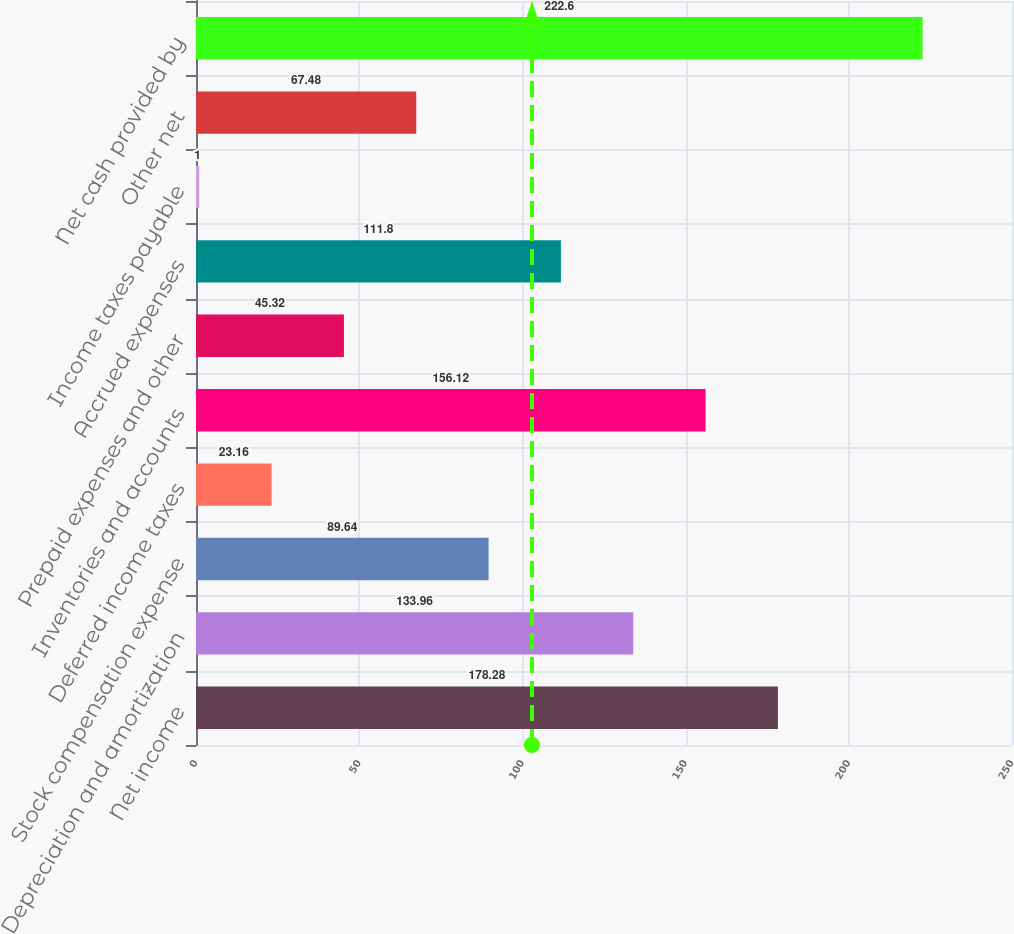<chart> <loc_0><loc_0><loc_500><loc_500><bar_chart><fcel>Net income<fcel>Depreciation and amortization<fcel>Stock compensation expense<fcel>Deferred income taxes<fcel>Inventories and accounts<fcel>Prepaid expenses and other<fcel>Accrued expenses<fcel>Income taxes payable<fcel>Other net<fcel>Net cash provided by<nl><fcel>178.28<fcel>133.96<fcel>89.64<fcel>23.16<fcel>156.12<fcel>45.32<fcel>111.8<fcel>1<fcel>67.48<fcel>222.6<nl></chart> 